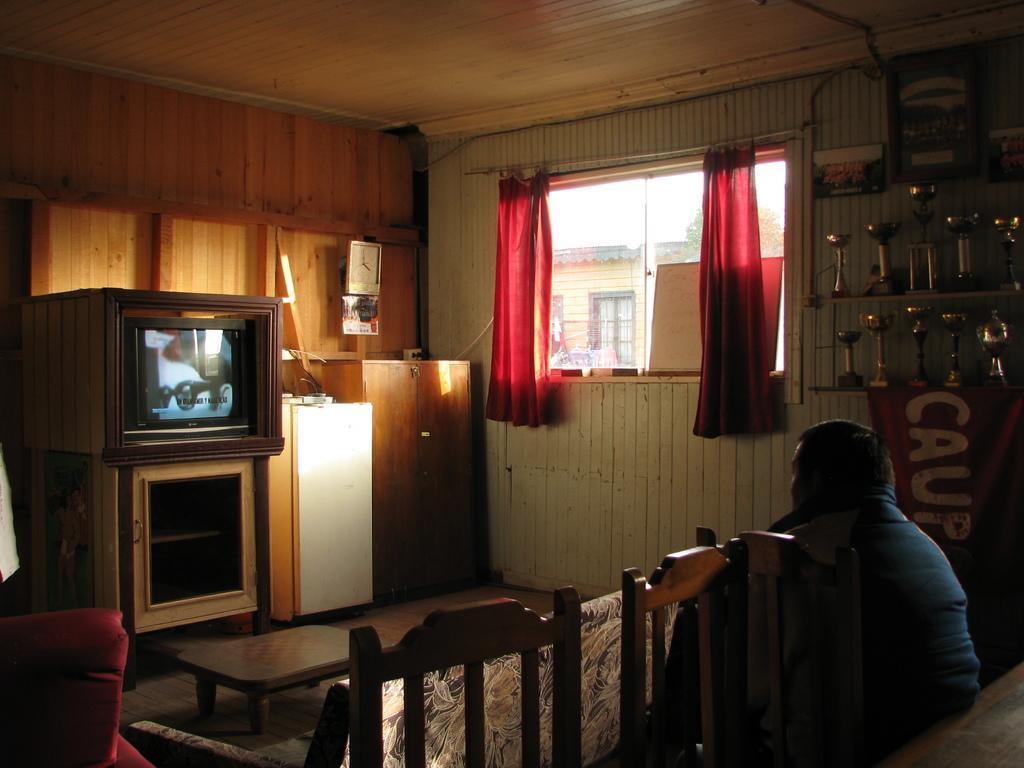How would you summarize this image in a sentence or two? In this image there is a person sitting, there are chairs ,couch, tables, television on the cupboard , refrigerator, trophies on the racks, window, curtains, clock attached to the wooden wall, and in the background there is a house, tree,sky. 